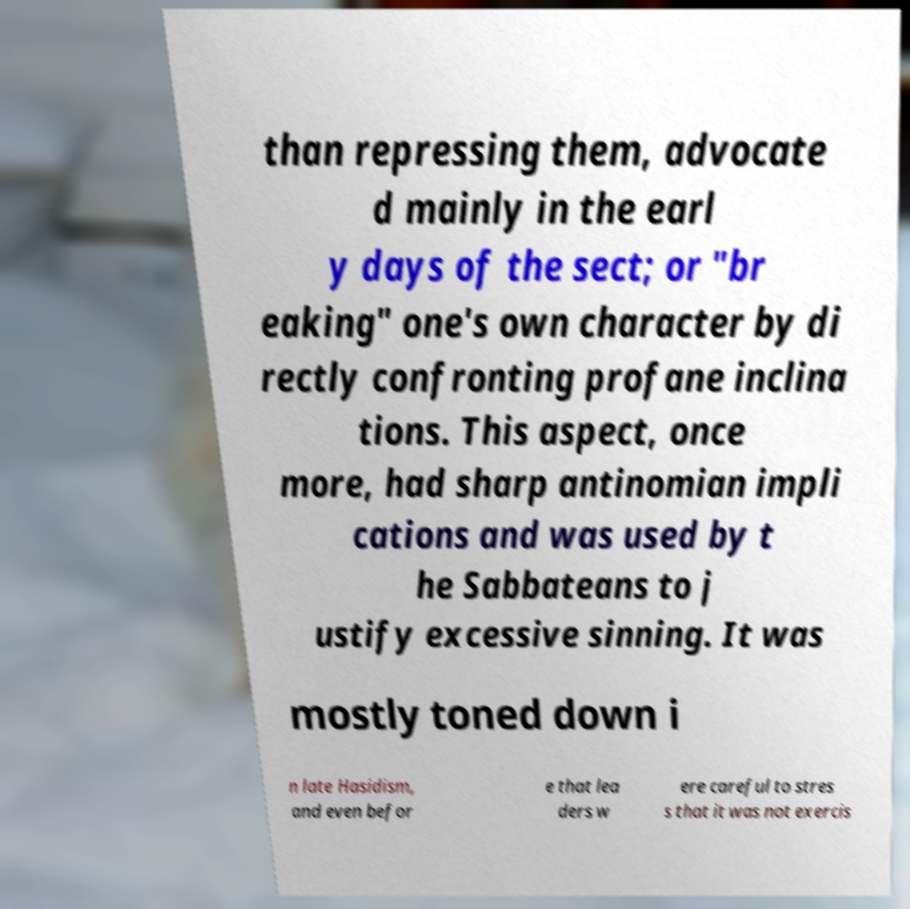Could you extract and type out the text from this image? than repressing them, advocate d mainly in the earl y days of the sect; or "br eaking" one's own character by di rectly confronting profane inclina tions. This aspect, once more, had sharp antinomian impli cations and was used by t he Sabbateans to j ustify excessive sinning. It was mostly toned down i n late Hasidism, and even befor e that lea ders w ere careful to stres s that it was not exercis 